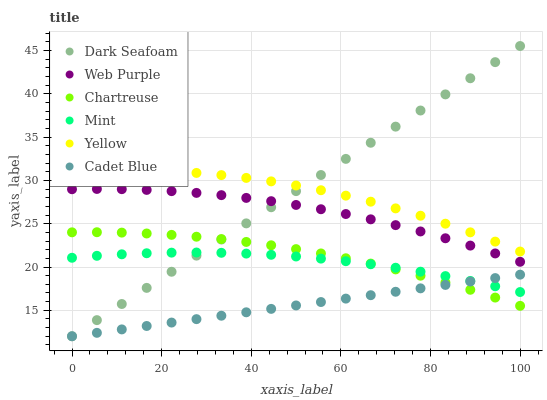Does Cadet Blue have the minimum area under the curve?
Answer yes or no. Yes. Does Dark Seafoam have the maximum area under the curve?
Answer yes or no. Yes. Does Web Purple have the minimum area under the curve?
Answer yes or no. No. Does Web Purple have the maximum area under the curve?
Answer yes or no. No. Is Cadet Blue the smoothest?
Answer yes or no. Yes. Is Yellow the roughest?
Answer yes or no. Yes. Is Web Purple the smoothest?
Answer yes or no. No. Is Web Purple the roughest?
Answer yes or no. No. Does Cadet Blue have the lowest value?
Answer yes or no. Yes. Does Web Purple have the lowest value?
Answer yes or no. No. Does Dark Seafoam have the highest value?
Answer yes or no. Yes. Does Web Purple have the highest value?
Answer yes or no. No. Is Web Purple less than Yellow?
Answer yes or no. Yes. Is Yellow greater than Chartreuse?
Answer yes or no. Yes. Does Chartreuse intersect Cadet Blue?
Answer yes or no. Yes. Is Chartreuse less than Cadet Blue?
Answer yes or no. No. Is Chartreuse greater than Cadet Blue?
Answer yes or no. No. Does Web Purple intersect Yellow?
Answer yes or no. No. 